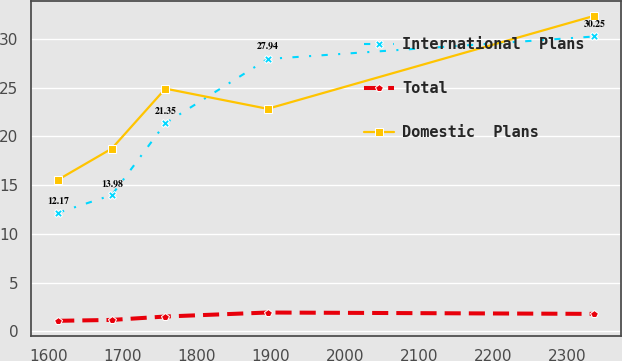<chart> <loc_0><loc_0><loc_500><loc_500><line_chart><ecel><fcel>International  Plans<fcel>Total<fcel>Domestic  Plans<nl><fcel>1612.62<fcel>12.17<fcel>1.08<fcel>15.56<nl><fcel>1685.03<fcel>13.98<fcel>1.17<fcel>18.75<nl><fcel>1757.44<fcel>21.35<fcel>1.52<fcel>24.9<nl><fcel>1895.48<fcel>27.94<fcel>1.93<fcel>22.83<nl><fcel>2336.7<fcel>30.25<fcel>1.79<fcel>32.37<nl></chart> 